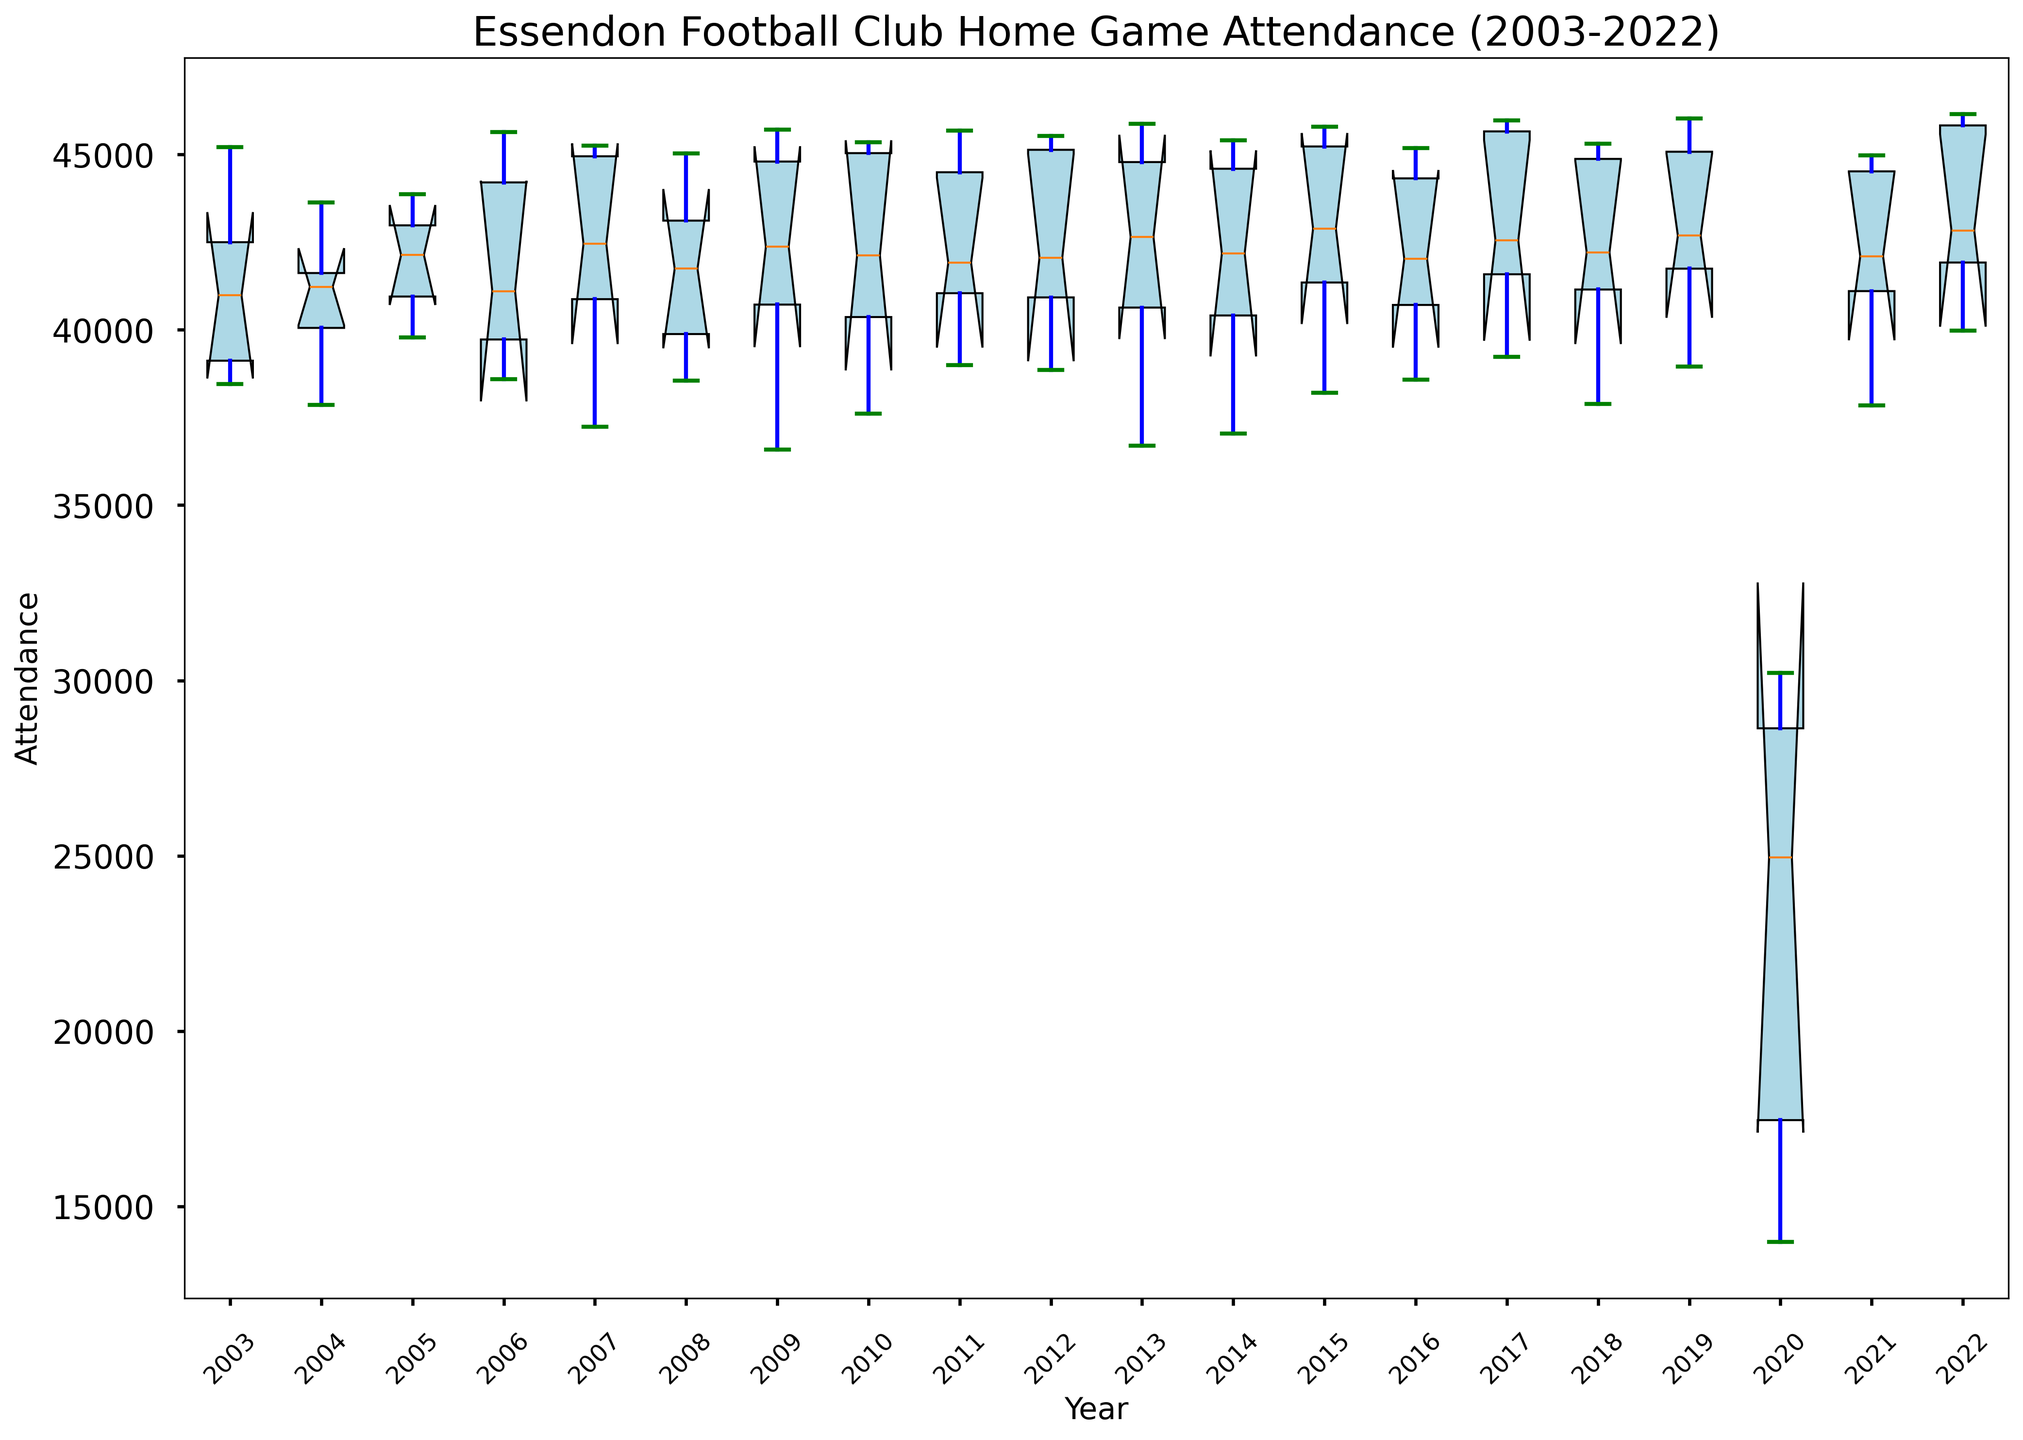What is the median attendance for Essendon Football Club home games in 2009? To find the median attendance for home games in 2009, locate the box plot for 2009. The middle line inside the box represents the median value.
Answer: 44800 Which year showed the lowest median attendance for home games? Identify the year whose box plot's median line (the line inside the box) is closest to the bottom compared to other years.
Answer: 2020 How did the median attendance in 2020 compare to the median attendance in 2021? Locate the median lines inside the boxes for both 2020 and 2021 and compare their heights. The median line for 2020 is significantly lower than that for 2021.
Answer: 2020 was lower What is the interquartile range (IQR) for the attendance in 2015? The IQR is the range between the first quartile (Q1, bottom edge of the box) and third quartile (Q3, top edge of the box) of the box plot for 2015. Subtract Q1 from Q3.
Answer: 45795 - 38200 = 7595 Which year had the smallest range of attendance values? The range is the difference between the top whisker and the bottom whisker. Identify the year with the smallest distance between these two points.
Answer: 2020 In which years did the maximum attendance exceed 46000? Look at the top whiskers of the box plots and find the years where the whiskers extend above 46000.
Answer: 2017, 2019, 2022 Was there any year with significant outliers, especially low attendances? If yes, which year was it, and what were the outliers? Outliers are shown as individual points outside the whiskers. Find the year(s) with outliers particularly lower than the rest of the data points.
Answer: 2020, e.g., 13985 How has the attendance trend changed between 2003 and 2022? Observe the position of the median lines across all years from 2003 to 2022 to understand the trend. There is a general stability with a significant drop in 2020 (possibly due to external factors like the COVID-19 pandemic) followed by a recovery.
Answer: Stable with a dip in 2020 What was the overall mean attendance for home games across all years, and did it vary significantly over the years? Calculate the mean of all median values (middle lines in the boxes) for each year. Although there were fluctuations, especially in 2020, the median values are relatively consistent.
Answer: Relatively consistent with some fluctuations Between 2013 and 2015, how did the range of attendance values change? Examine the whiskers' extent for the years 2013 to 2015, noting whether the gap between the top and bottom whiskers increased, decreased, or remained stable.
Answer: Increased 